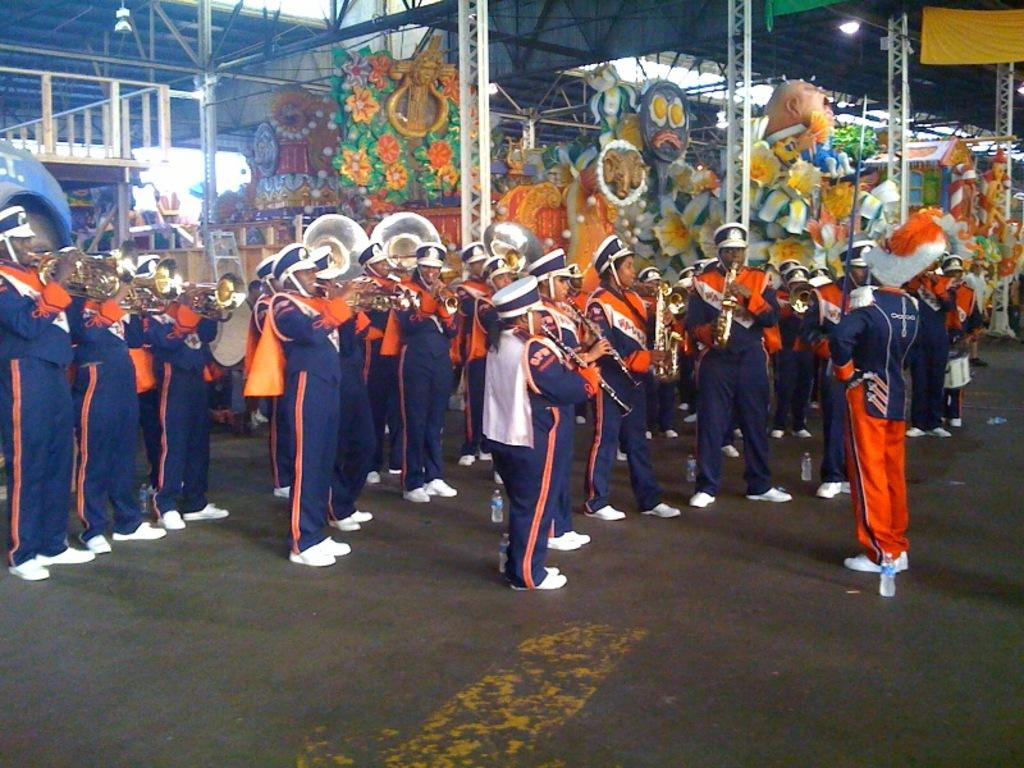What are the people in the image doing? Some of the people are playing musical instruments. What architectural features can be seen in the image? There are pillars in the image. What type of lighting is present in the image? There are lights in the image. What structural elements can be seen in the image? Metal rods are present in the image. What other objects can be seen in the image besides the people and musical instruments? There are other objects in the image. How many clocks are visible on the pillars in the image? There is no mention of clocks in the image, so it is not possible to determine their presence or quantity. What type of stitch is being used to hold the metal rods together in the image? There is no indication of any stitching in the image, as the metal rods are likely held together by other means, such as welding or bolts. 